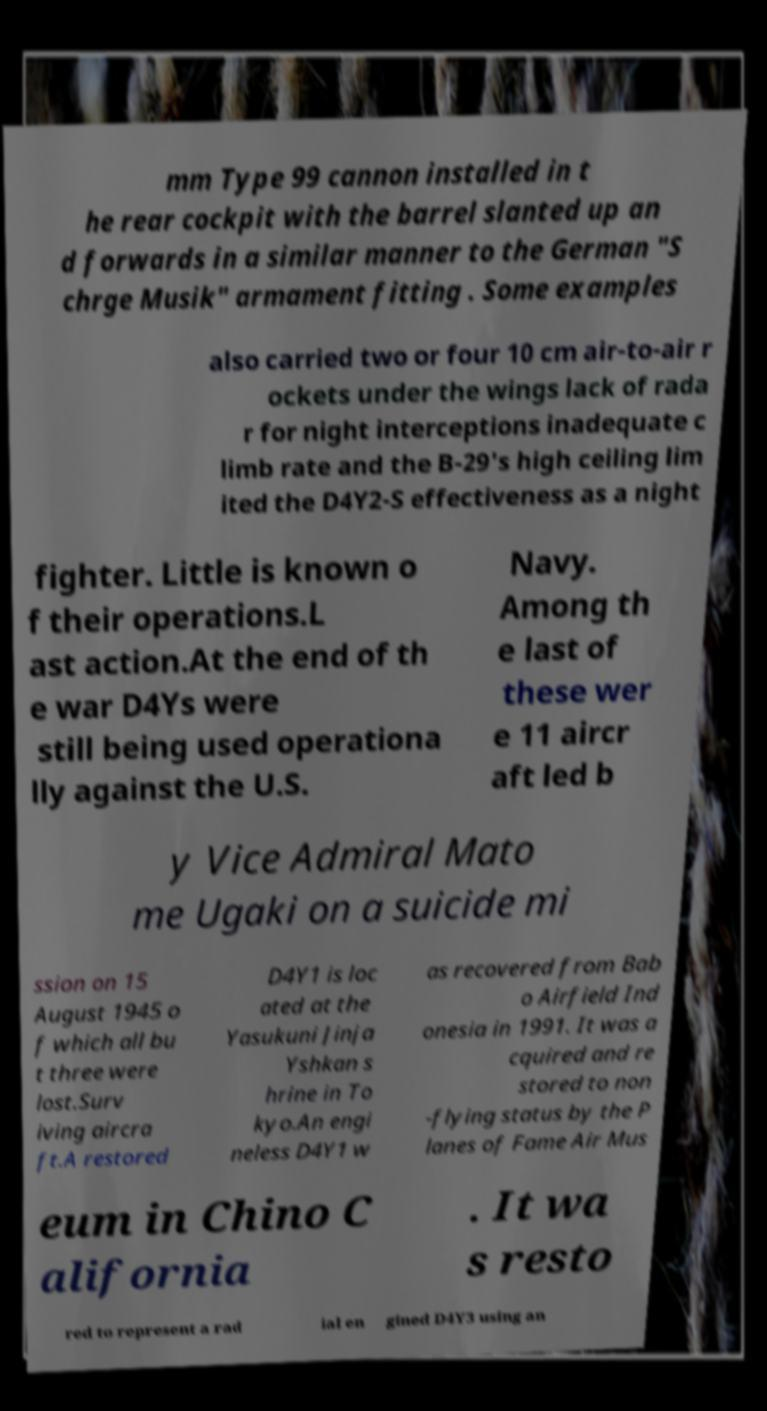Please read and relay the text visible in this image. What does it say? mm Type 99 cannon installed in t he rear cockpit with the barrel slanted up an d forwards in a similar manner to the German "S chrge Musik" armament fitting . Some examples also carried two or four 10 cm air-to-air r ockets under the wings lack of rada r for night interceptions inadequate c limb rate and the B-29's high ceiling lim ited the D4Y2-S effectiveness as a night fighter. Little is known o f their operations.L ast action.At the end of th e war D4Ys were still being used operationa lly against the U.S. Navy. Among th e last of these wer e 11 aircr aft led b y Vice Admiral Mato me Ugaki on a suicide mi ssion on 15 August 1945 o f which all bu t three were lost.Surv iving aircra ft.A restored D4Y1 is loc ated at the Yasukuni Jinja Yshkan s hrine in To kyo.An engi neless D4Y1 w as recovered from Bab o Airfield Ind onesia in 1991. It was a cquired and re stored to non -flying status by the P lanes of Fame Air Mus eum in Chino C alifornia . It wa s resto red to represent a rad ial en gined D4Y3 using an 